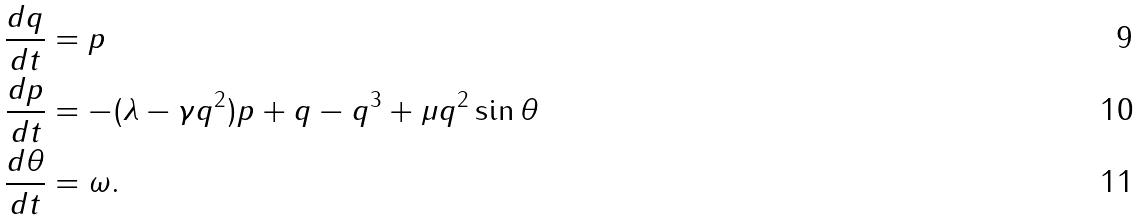Convert formula to latex. <formula><loc_0><loc_0><loc_500><loc_500>\frac { d q } { d t } & = p \\ \frac { d p } { d t } & = - ( \lambda - \gamma q ^ { 2 } ) p + q - q ^ { 3 } + \mu q ^ { 2 } \sin \theta \\ \frac { d \theta } { d t } & = \omega .</formula> 